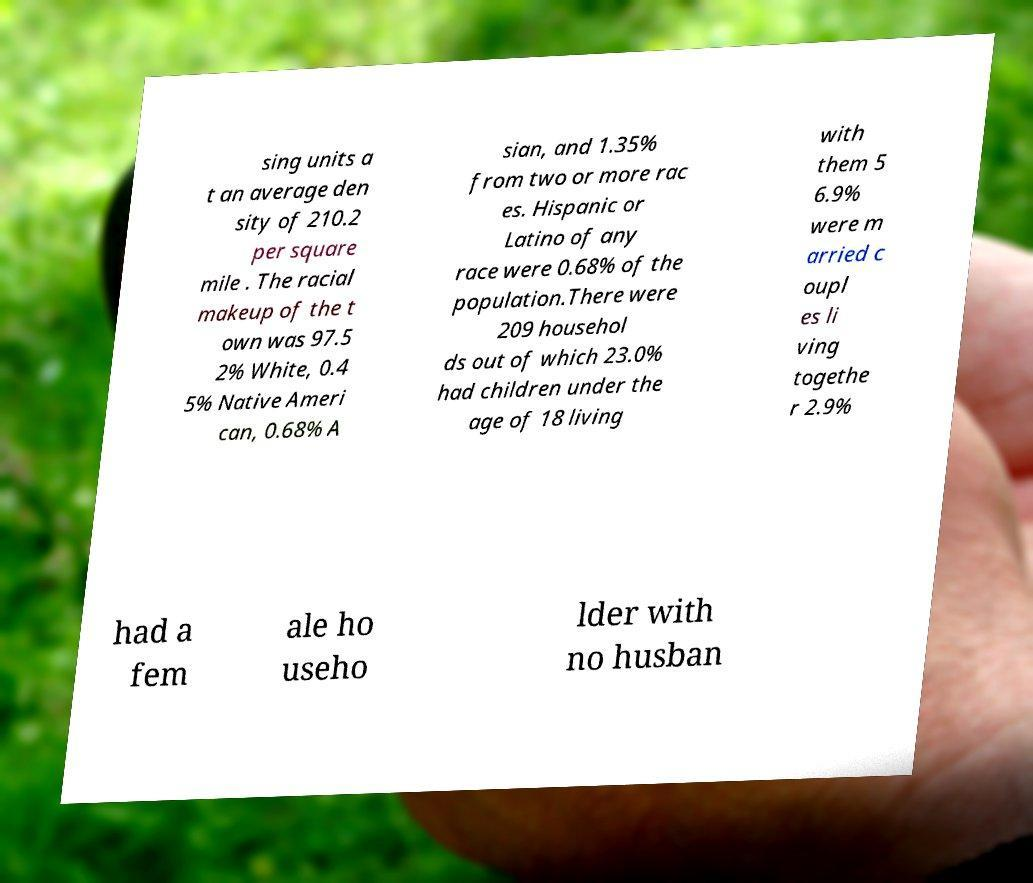Could you assist in decoding the text presented in this image and type it out clearly? sing units a t an average den sity of 210.2 per square mile . The racial makeup of the t own was 97.5 2% White, 0.4 5% Native Ameri can, 0.68% A sian, and 1.35% from two or more rac es. Hispanic or Latino of any race were 0.68% of the population.There were 209 househol ds out of which 23.0% had children under the age of 18 living with them 5 6.9% were m arried c oupl es li ving togethe r 2.9% had a fem ale ho useho lder with no husban 